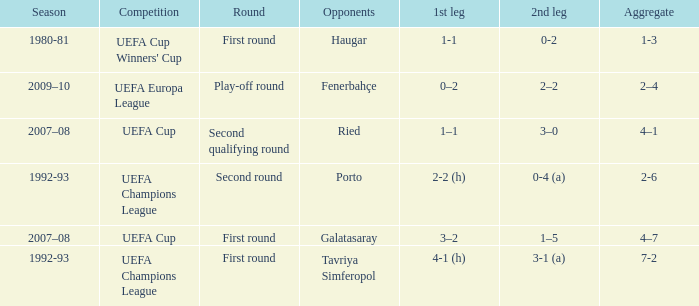What is the total number of round where opponents is haugar 1.0. 